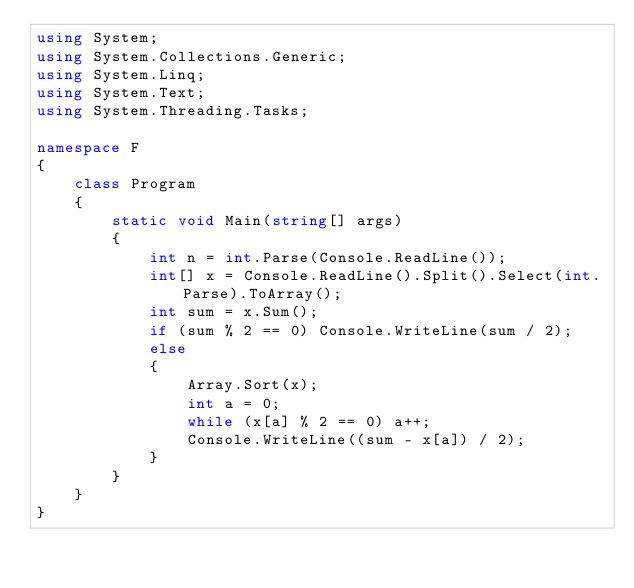<code> <loc_0><loc_0><loc_500><loc_500><_C#_>using System;
using System.Collections.Generic;
using System.Linq;
using System.Text;
using System.Threading.Tasks;

namespace F
{
    class Program
    {
        static void Main(string[] args)
        {
            int n = int.Parse(Console.ReadLine());
            int[] x = Console.ReadLine().Split().Select(int.Parse).ToArray();
            int sum = x.Sum();
            if (sum % 2 == 0) Console.WriteLine(sum / 2);
            else
            {
                Array.Sort(x);
                int a = 0;
                while (x[a] % 2 == 0) a++;
                Console.WriteLine((sum - x[a]) / 2);
            }
        }
    }
}
</code> 